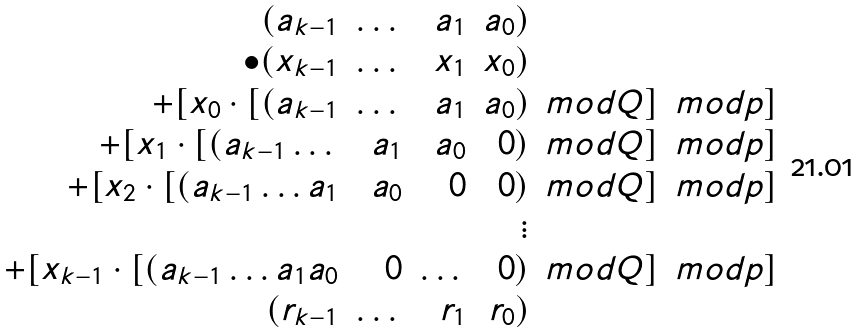Convert formula to latex. <formula><loc_0><loc_0><loc_500><loc_500>\begin{array} { r r r r l l } ( a _ { k - 1 } & \dots & a _ { 1 } & a _ { 0 } ) & & \\ \bullet ( x _ { k - 1 } & \dots & x _ { 1 } & x _ { 0 } ) & & \\ + [ x _ { 0 } \cdot [ ( a _ { k - 1 } & \dots & a _ { 1 } & a _ { 0 } ) & m o d Q ] & m o d p ] \\ + [ x _ { 1 } \cdot [ ( a _ { k - 1 } \dots & a _ { 1 } & a _ { 0 } & 0 ) & m o d Q ] & m o d p ] \\ + [ x _ { 2 } \cdot [ ( a _ { k - 1 } \dots a _ { 1 } & a _ { 0 } & 0 & 0 ) & m o d Q ] & m o d p ] \\ & & & \vdots & & \\ + [ x _ { k - 1 } \cdot [ ( a _ { k - 1 } \dots a _ { 1 } a _ { 0 } & 0 & \dots & 0 ) & m o d Q ] & m o d p ] \\ ( r _ { k - 1 } & \dots & r _ { 1 } & r _ { 0 } ) & & \end{array}</formula> 